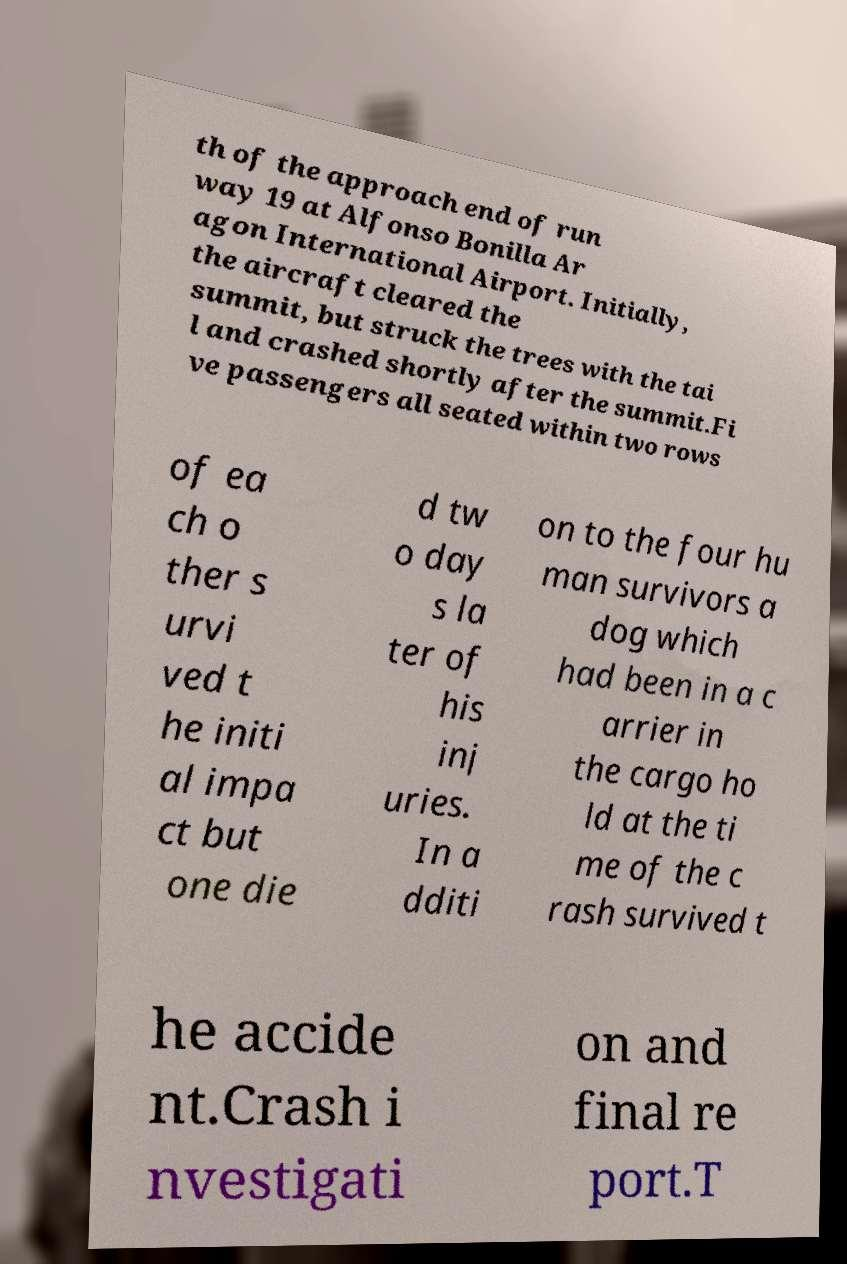There's text embedded in this image that I need extracted. Can you transcribe it verbatim? th of the approach end of run way 19 at Alfonso Bonilla Ar agon International Airport. Initially, the aircraft cleared the summit, but struck the trees with the tai l and crashed shortly after the summit.Fi ve passengers all seated within two rows of ea ch o ther s urvi ved t he initi al impa ct but one die d tw o day s la ter of his inj uries. In a dditi on to the four hu man survivors a dog which had been in a c arrier in the cargo ho ld at the ti me of the c rash survived t he accide nt.Crash i nvestigati on and final re port.T 